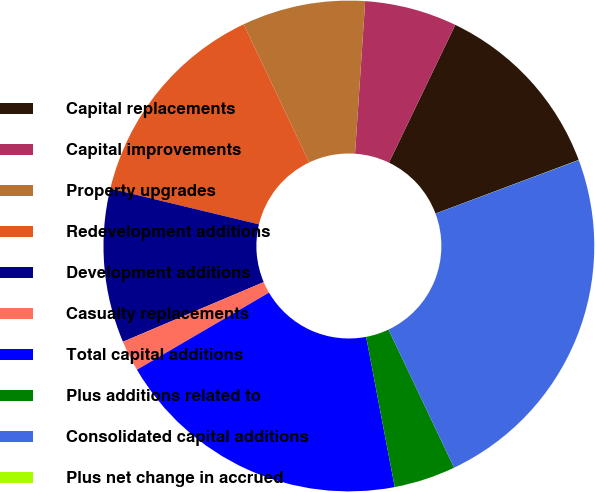<chart> <loc_0><loc_0><loc_500><loc_500><pie_chart><fcel>Capital replacements<fcel>Capital improvements<fcel>Property upgrades<fcel>Redevelopment additions<fcel>Development additions<fcel>Casualty replacements<fcel>Total capital additions<fcel>Plus additions related to<fcel>Consolidated capital additions<fcel>Plus net change in accrued<nl><fcel>12.16%<fcel>6.08%<fcel>8.11%<fcel>14.19%<fcel>10.14%<fcel>2.03%<fcel>19.58%<fcel>4.06%<fcel>23.64%<fcel>0.01%<nl></chart> 